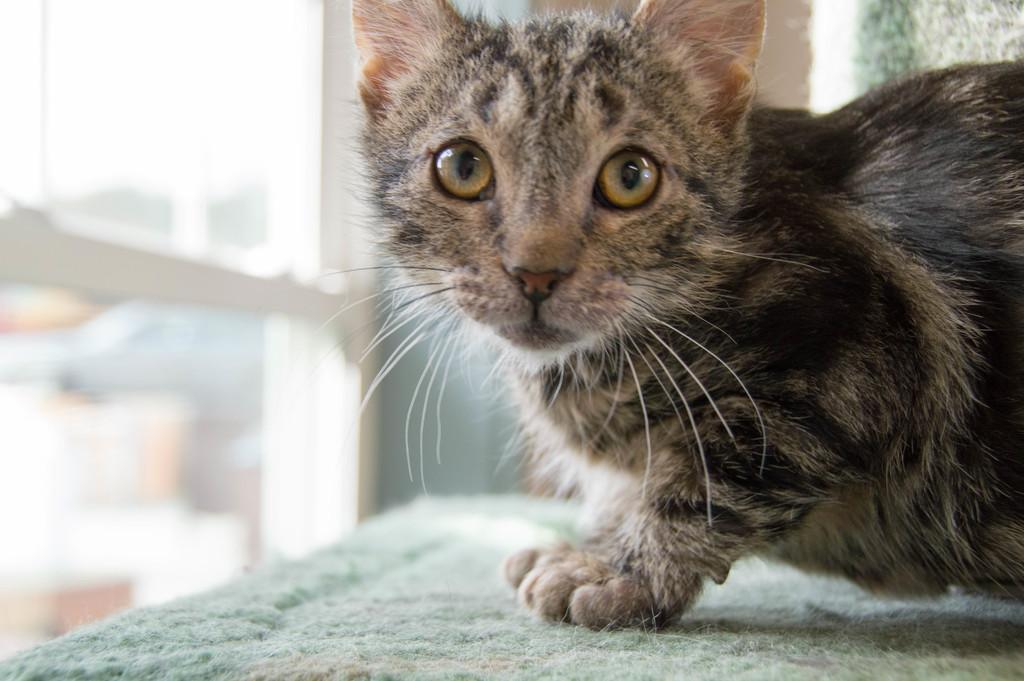What type of animal is in the image? There is a cat in the image. Where is the cat located in the image? The cat is present over a place. What can be seen through the glass window in the image? The glass window appears blurry, so it is difficult to see through it clearly. What type of plot is visible through the glass window in the image? There is no plot visible through the glass window in the image, as it appears blurry and does not show any clear details. 